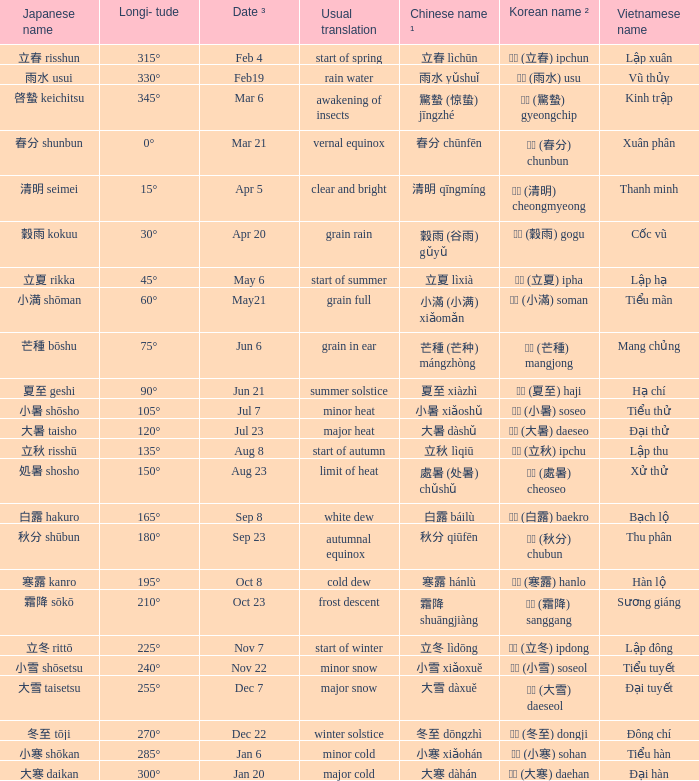WHICH Vietnamese name has a Chinese name ¹ of 芒種 (芒种) mángzhòng? Mang chủng. 